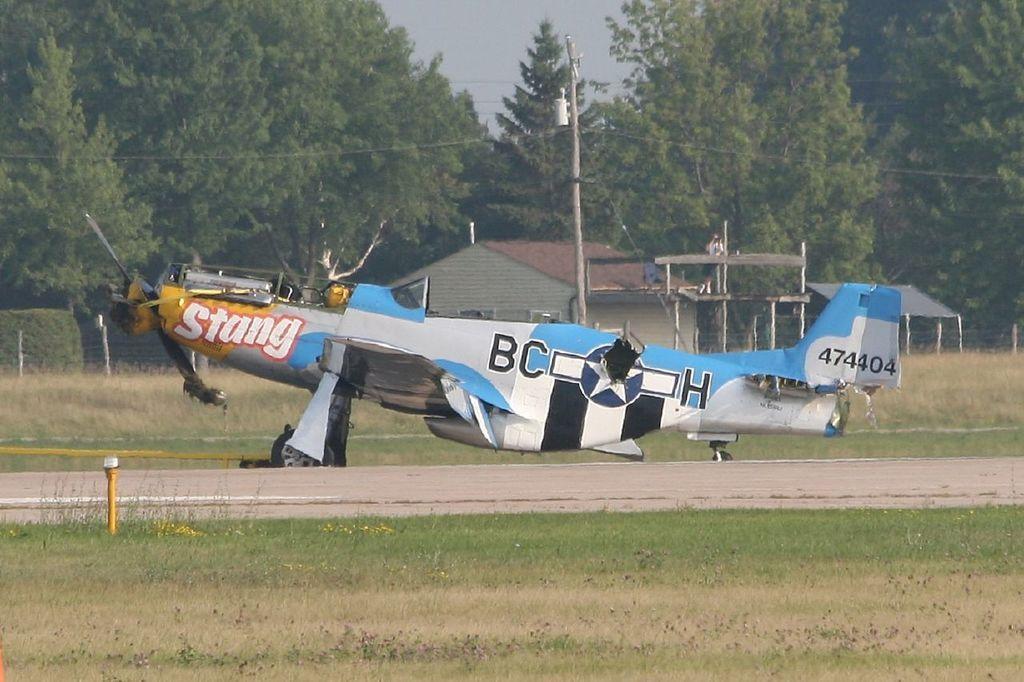Can you describe this image briefly? In the image there is an aircraft on the ground and around the aircraft there is a lot of grass and in the background there is a house. Behind the house there are many trees. 